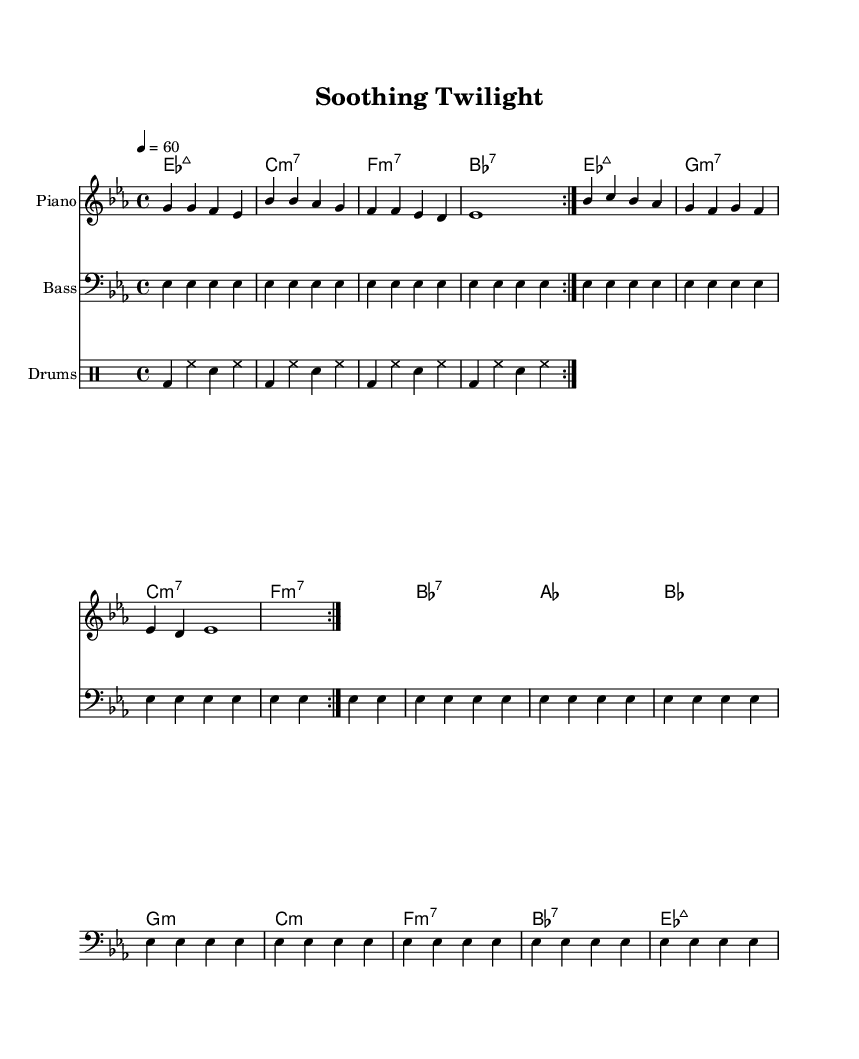What is the key signature of this music? The key signature is E-flat major, which contains three flats: B-flat, E-flat, and A-flat. This can be identified by looking at the key signature at the beginning of the sheet music.
Answer: E-flat major What is the time signature of this piece? The time signature is 4/4, which means there are four beats in each measure and the quarter note is one beat. This information is indicated next to the key signature at the beginning of the sheet music.
Answer: 4/4 What is the tempo marking for this piece? The tempo marking is a quarter note equals 60 beats per minute, indicating a slow and relaxed pace for the music. This is noted in the tempo indication found at the beginning of the score.
Answer: 60 How many times is the melody repeated? The melody is repeated two times, as indicated by the "volta" directive in the notation, which shows that the melody section has a repeat sign followed by a numerical indication.
Answer: 2 What is the primary type of chord used in the harmonic progression? The primary type of chord used is major 7th chords, specifically E-flat major 7th in the first measure, which is featured throughout the harmony section of the music.
Answer: Major 7th What instrument plays the melody? The piano plays the melody, which is notated in the staff labeled "Piano" at the beginning of the score. This instrument is typically used for melodies in R&B ballads.
Answer: Piano What rhythm pattern is used in the drum part? The rhythm pattern consists of a bass drum and hi-hat on the quarter notes paired with a snare drum on specific beats. This can be seen in the drum notation, where each measure consists of repeated rhythmic patterns.
Answer: Bass and hi-hat 